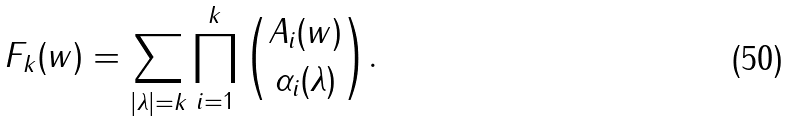Convert formula to latex. <formula><loc_0><loc_0><loc_500><loc_500>F _ { k } ( w ) = \sum _ { | \lambda | = k } \prod _ { i = 1 } ^ { k } { A _ { i } ( w ) \choose \alpha _ { i } ( \lambda ) } .</formula> 